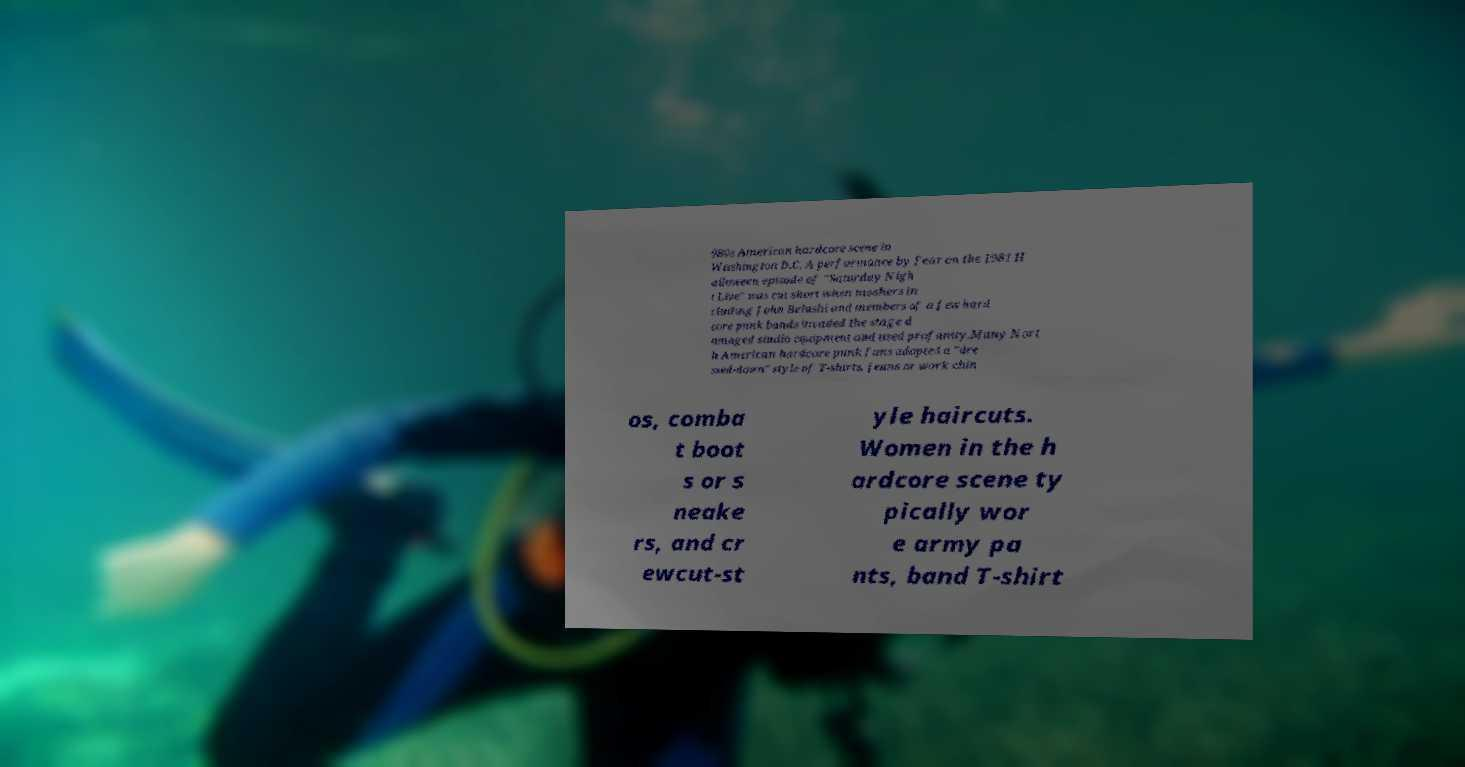Could you assist in decoding the text presented in this image and type it out clearly? 980s American hardcore scene in Washington D.C. A performance by Fear on the 1981 H alloween episode of "Saturday Nigh t Live" was cut short when moshers in cluding John Belushi and members of a few hard core punk bands invaded the stage d amaged studio equipment and used profanity.Many Nort h American hardcore punk fans adopted a "dre ssed-down" style of T-shirts, jeans or work chin os, comba t boot s or s neake rs, and cr ewcut-st yle haircuts. Women in the h ardcore scene ty pically wor e army pa nts, band T-shirt 